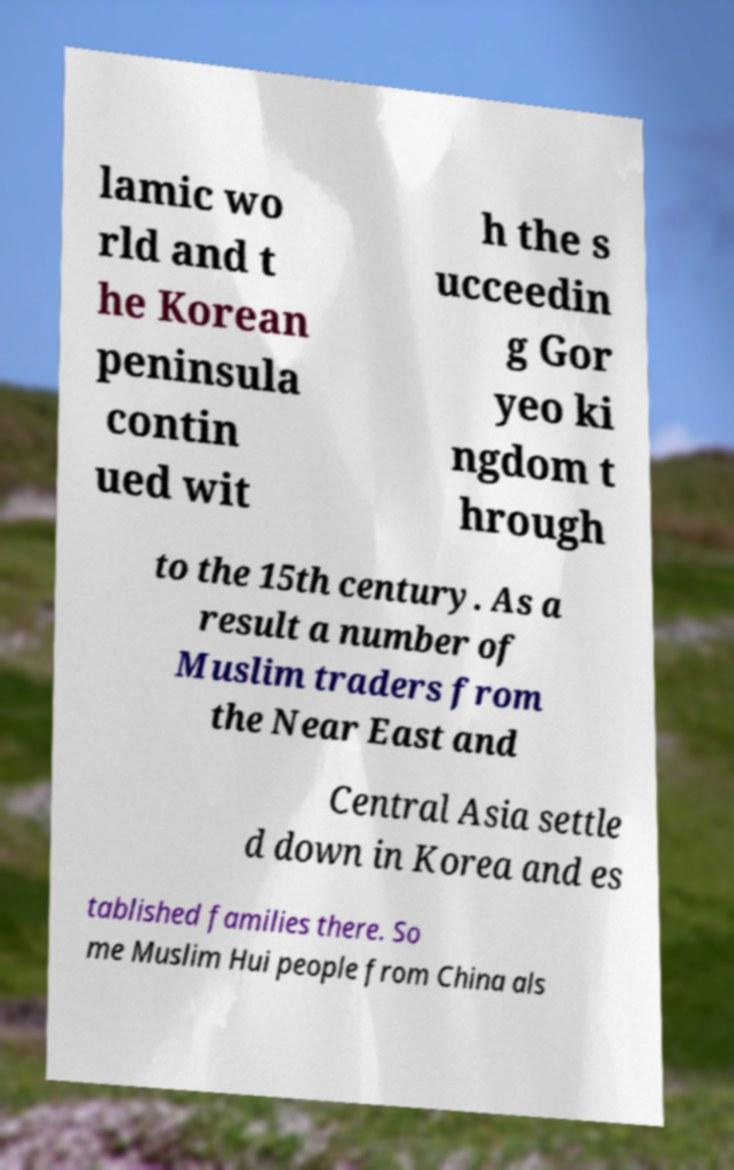For documentation purposes, I need the text within this image transcribed. Could you provide that? lamic wo rld and t he Korean peninsula contin ued wit h the s ucceedin g Gor yeo ki ngdom t hrough to the 15th century. As a result a number of Muslim traders from the Near East and Central Asia settle d down in Korea and es tablished families there. So me Muslim Hui people from China als 